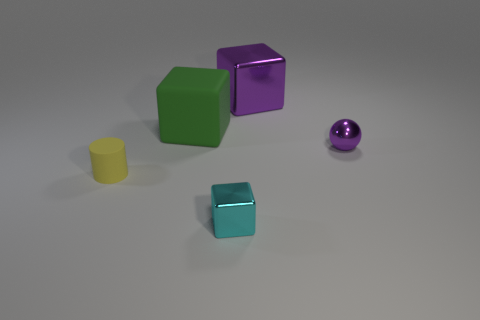How many purple things are either small objects or small metallic cubes?
Your answer should be compact. 1. What number of tiny metallic things are the same shape as the small matte object?
Keep it short and to the point. 0. How many metal spheres are the same size as the yellow rubber cylinder?
Your answer should be very brief. 1. There is a cyan thing that is the same shape as the big purple thing; what is its material?
Your answer should be compact. Metal. There is a big object that is right of the big green rubber block; what is its color?
Give a very brief answer. Purple. Are there more cubes on the right side of the cyan block than tiny gray metallic blocks?
Keep it short and to the point. Yes. The tiny cylinder is what color?
Offer a terse response. Yellow. There is a large thing left of the metallic cube to the right of the tiny shiny object that is to the left of the small purple shiny object; what shape is it?
Your answer should be compact. Cube. There is a object that is both in front of the big green object and right of the small block; what is its material?
Keep it short and to the point. Metal. What is the shape of the big rubber thing that is behind the tiny cyan shiny thing that is on the right side of the large rubber thing?
Provide a short and direct response. Cube. 